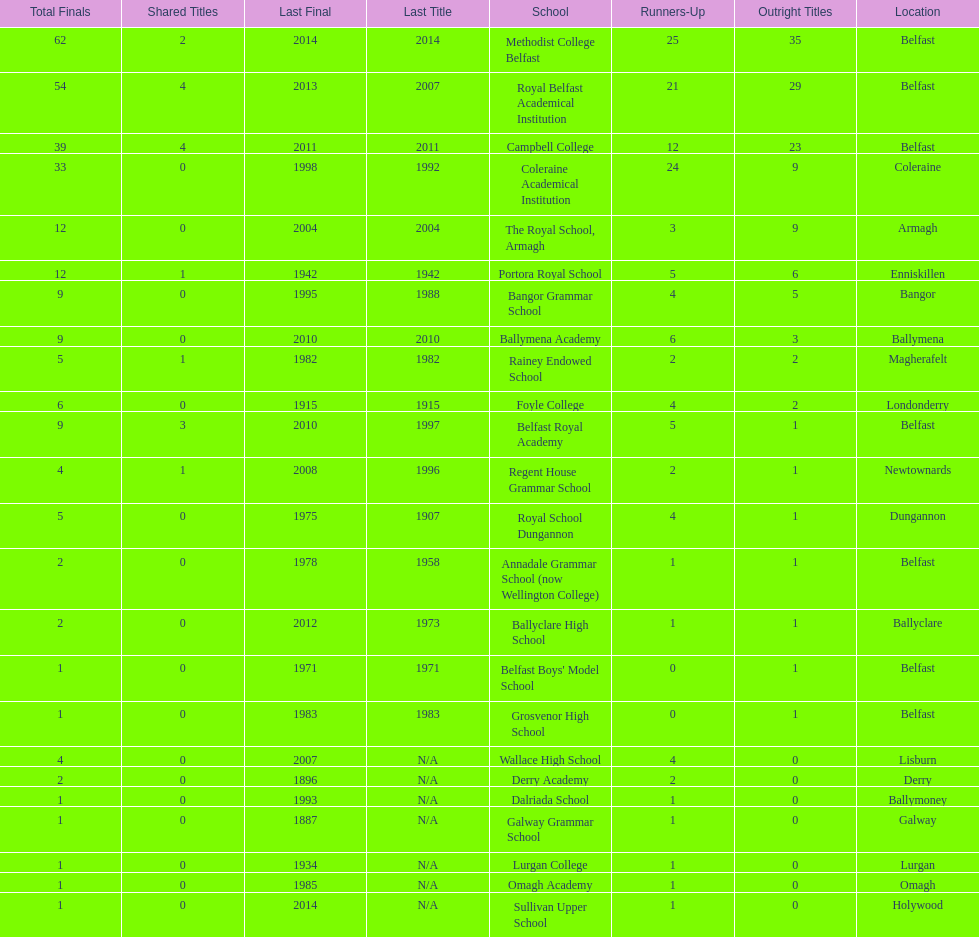How many educational institutions possess 5 or more outright titles? 7. 